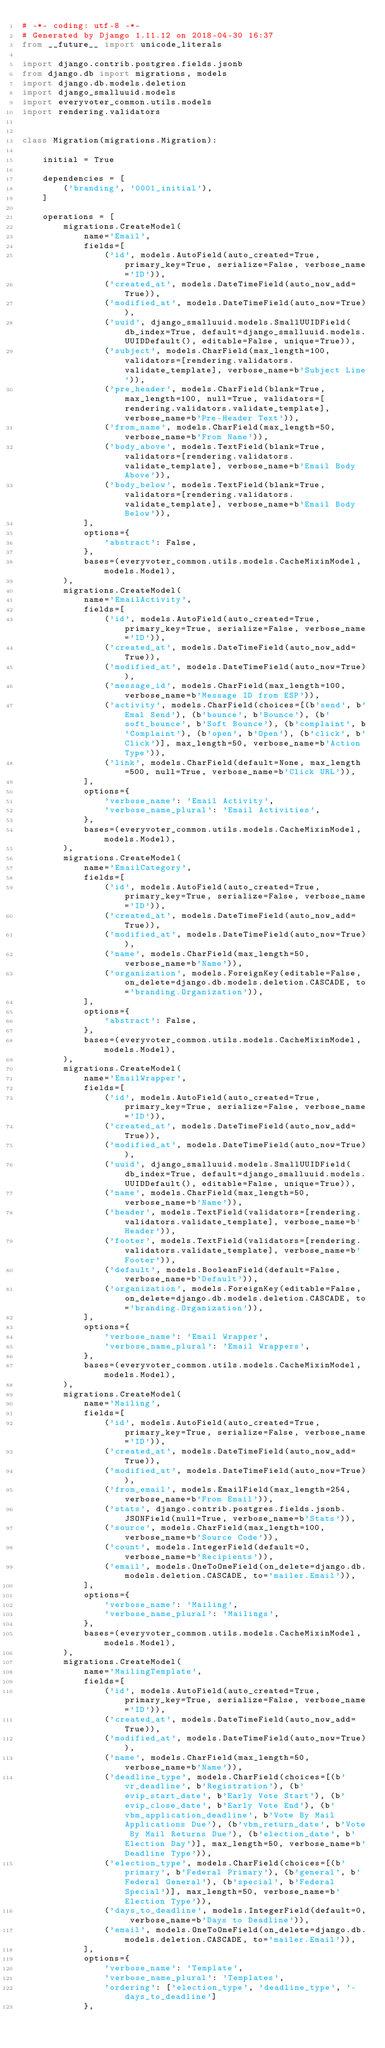<code> <loc_0><loc_0><loc_500><loc_500><_Python_># -*- coding: utf-8 -*-
# Generated by Django 1.11.12 on 2018-04-30 16:37
from __future__ import unicode_literals

import django.contrib.postgres.fields.jsonb
from django.db import migrations, models
import django.db.models.deletion
import django_smalluuid.models
import everyvoter_common.utils.models
import rendering.validators


class Migration(migrations.Migration):

    initial = True

    dependencies = [
        ('branding', '0001_initial'),
    ]

    operations = [
        migrations.CreateModel(
            name='Email',
            fields=[
                ('id', models.AutoField(auto_created=True, primary_key=True, serialize=False, verbose_name='ID')),
                ('created_at', models.DateTimeField(auto_now_add=True)),
                ('modified_at', models.DateTimeField(auto_now=True)),
                ('uuid', django_smalluuid.models.SmallUUIDField(db_index=True, default=django_smalluuid.models.UUIDDefault(), editable=False, unique=True)),
                ('subject', models.CharField(max_length=100, validators=[rendering.validators.validate_template], verbose_name=b'Subject Line')),
                ('pre_header', models.CharField(blank=True, max_length=100, null=True, validators=[rendering.validators.validate_template], verbose_name=b'Pre-Header Text')),
                ('from_name', models.CharField(max_length=50, verbose_name=b'From Name')),
                ('body_above', models.TextField(blank=True, validators=[rendering.validators.validate_template], verbose_name=b'Email Body Above')),
                ('body_below', models.TextField(blank=True, validators=[rendering.validators.validate_template], verbose_name=b'Email Body Below')),
            ],
            options={
                'abstract': False,
            },
            bases=(everyvoter_common.utils.models.CacheMixinModel, models.Model),
        ),
        migrations.CreateModel(
            name='EmailActivity',
            fields=[
                ('id', models.AutoField(auto_created=True, primary_key=True, serialize=False, verbose_name='ID')),
                ('created_at', models.DateTimeField(auto_now_add=True)),
                ('modified_at', models.DateTimeField(auto_now=True)),
                ('message_id', models.CharField(max_length=100, verbose_name=b'Message ID from ESP')),
                ('activity', models.CharField(choices=[(b'send', b'Emal Send'), (b'bounce', b'Bounce'), (b'soft_bounce', b'Soft Bounce'), (b'complaint', b'Complaint'), (b'open', b'Open'), (b'click', b'Click')], max_length=50, verbose_name=b'Action Type')),
                ('link', models.CharField(default=None, max_length=500, null=True, verbose_name=b'Click URL')),
            ],
            options={
                'verbose_name': 'Email Activity',
                'verbose_name_plural': 'Email Activities',
            },
            bases=(everyvoter_common.utils.models.CacheMixinModel, models.Model),
        ),
        migrations.CreateModel(
            name='EmailCategory',
            fields=[
                ('id', models.AutoField(auto_created=True, primary_key=True, serialize=False, verbose_name='ID')),
                ('created_at', models.DateTimeField(auto_now_add=True)),
                ('modified_at', models.DateTimeField(auto_now=True)),
                ('name', models.CharField(max_length=50, verbose_name=b'Name')),
                ('organization', models.ForeignKey(editable=False, on_delete=django.db.models.deletion.CASCADE, to='branding.Organization')),
            ],
            options={
                'abstract': False,
            },
            bases=(everyvoter_common.utils.models.CacheMixinModel, models.Model),
        ),
        migrations.CreateModel(
            name='EmailWrapper',
            fields=[
                ('id', models.AutoField(auto_created=True, primary_key=True, serialize=False, verbose_name='ID')),
                ('created_at', models.DateTimeField(auto_now_add=True)),
                ('modified_at', models.DateTimeField(auto_now=True)),
                ('uuid', django_smalluuid.models.SmallUUIDField(db_index=True, default=django_smalluuid.models.UUIDDefault(), editable=False, unique=True)),
                ('name', models.CharField(max_length=50, verbose_name=b'Name')),
                ('header', models.TextField(validators=[rendering.validators.validate_template], verbose_name=b'Header')),
                ('footer', models.TextField(validators=[rendering.validators.validate_template], verbose_name=b'Footer')),
                ('default', models.BooleanField(default=False, verbose_name=b'Default')),
                ('organization', models.ForeignKey(editable=False, on_delete=django.db.models.deletion.CASCADE, to='branding.Organization')),
            ],
            options={
                'verbose_name': 'Email Wrapper',
                'verbose_name_plural': 'Email Wrappers',
            },
            bases=(everyvoter_common.utils.models.CacheMixinModel, models.Model),
        ),
        migrations.CreateModel(
            name='Mailing',
            fields=[
                ('id', models.AutoField(auto_created=True, primary_key=True, serialize=False, verbose_name='ID')),
                ('created_at', models.DateTimeField(auto_now_add=True)),
                ('modified_at', models.DateTimeField(auto_now=True)),
                ('from_email', models.EmailField(max_length=254, verbose_name=b'From Email')),
                ('stats', django.contrib.postgres.fields.jsonb.JSONField(null=True, verbose_name=b'Stats')),
                ('source', models.CharField(max_length=100, verbose_name=b'Source Code')),
                ('count', models.IntegerField(default=0, verbose_name=b'Recipients')),
                ('email', models.OneToOneField(on_delete=django.db.models.deletion.CASCADE, to='mailer.Email')),
            ],
            options={
                'verbose_name': 'Mailing',
                'verbose_name_plural': 'Mailings',
            },
            bases=(everyvoter_common.utils.models.CacheMixinModel, models.Model),
        ),
        migrations.CreateModel(
            name='MailingTemplate',
            fields=[
                ('id', models.AutoField(auto_created=True, primary_key=True, serialize=False, verbose_name='ID')),
                ('created_at', models.DateTimeField(auto_now_add=True)),
                ('modified_at', models.DateTimeField(auto_now=True)),
                ('name', models.CharField(max_length=50, verbose_name=b'Name')),
                ('deadline_type', models.CharField(choices=[(b'vr_deadline', b'Registration'), (b'evip_start_date', b'Early Vote Start'), (b'evip_close_date', b'Early Vote End'), (b'vbm_application_deadline', b'Vote By Mail Applications Due'), (b'vbm_return_date', b'Vote By Mail Returns Due'), (b'election_date', b'Election Day')], max_length=50, verbose_name=b'Deadline Type')),
                ('election_type', models.CharField(choices=[(b'primary', b'Federal Primary'), (b'general', b'Federal General'), (b'special', b'Federal Special')], max_length=50, verbose_name=b'Election Type')),
                ('days_to_deadline', models.IntegerField(default=0, verbose_name=b'Days to Deadline')),
                ('email', models.OneToOneField(on_delete=django.db.models.deletion.CASCADE, to='mailer.Email')),
            ],
            options={
                'verbose_name': 'Template',
                'verbose_name_plural': 'Templates',
                'ordering': ['election_type', 'deadline_type', '-days_to_deadline']
            },</code> 